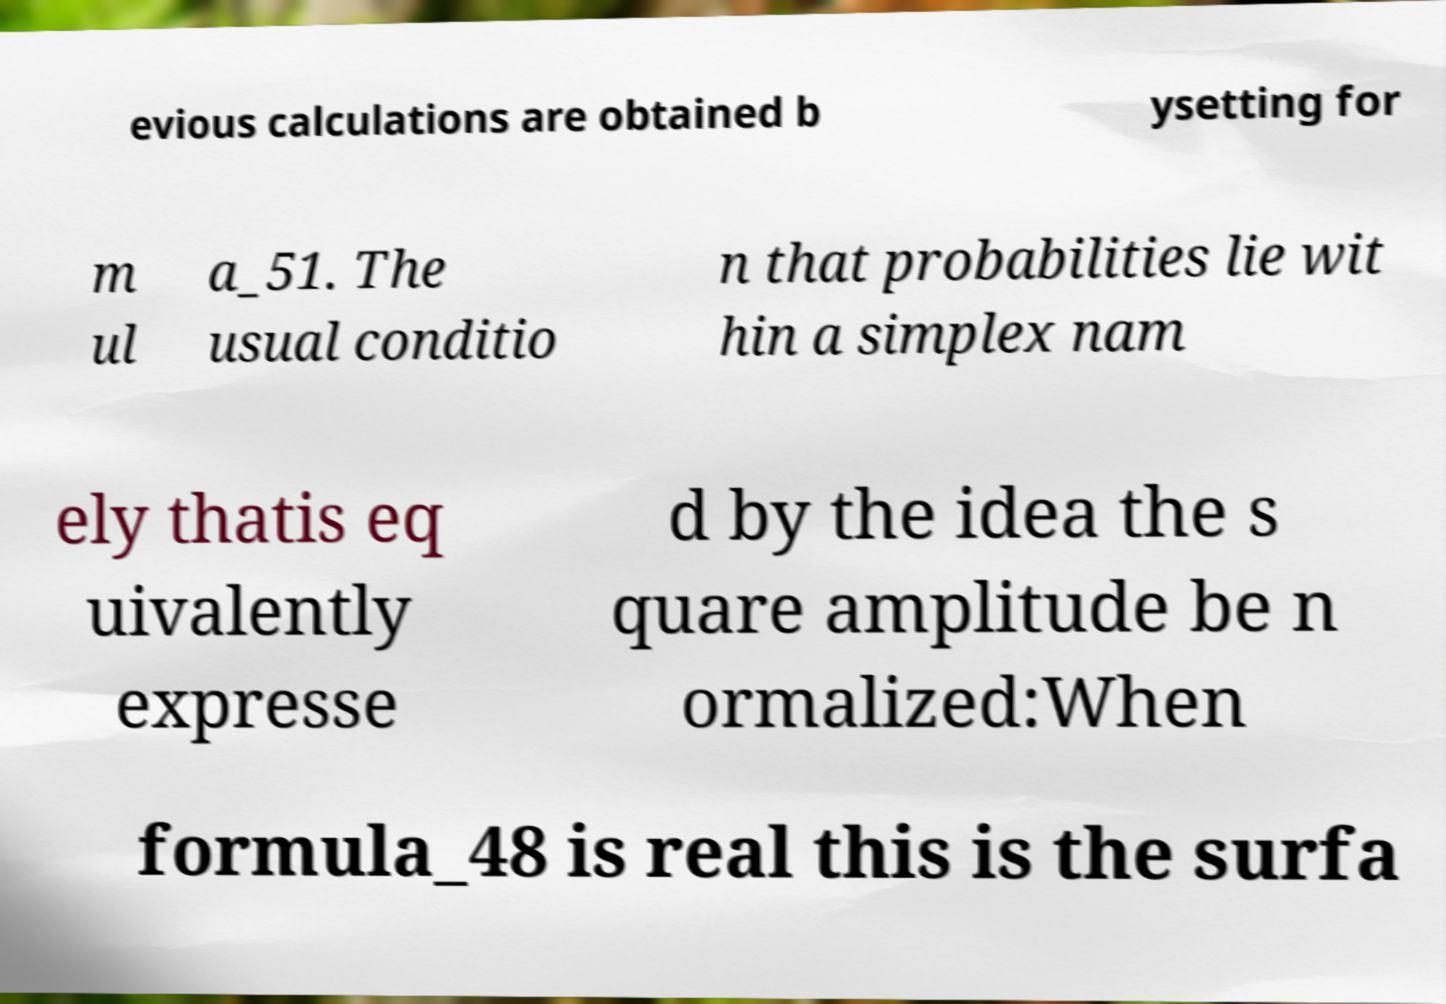Can you accurately transcribe the text from the provided image for me? evious calculations are obtained b ysetting for m ul a_51. The usual conditio n that probabilities lie wit hin a simplex nam ely thatis eq uivalently expresse d by the idea the s quare amplitude be n ormalized:When formula_48 is real this is the surfa 